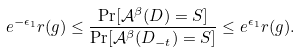Convert formula to latex. <formula><loc_0><loc_0><loc_500><loc_500>e ^ { - \epsilon _ { 1 } } r ( g ) \leq \frac { \Pr [ \mathcal { A } ^ { \beta } ( D ) = S ] } { \Pr [ \mathcal { A } ^ { \beta } ( D _ { - t } ) = S ] } \leq e ^ { \epsilon _ { 1 } } r ( g ) .</formula> 